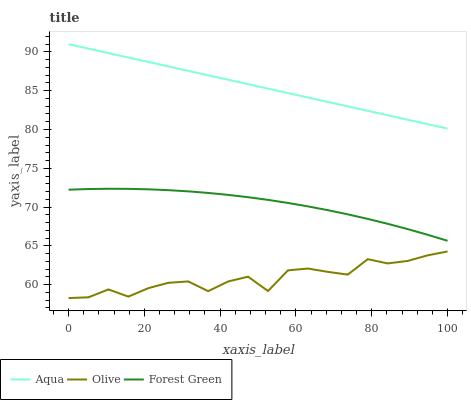Does Olive have the minimum area under the curve?
Answer yes or no. Yes. Does Aqua have the maximum area under the curve?
Answer yes or no. Yes. Does Forest Green have the minimum area under the curve?
Answer yes or no. No. Does Forest Green have the maximum area under the curve?
Answer yes or no. No. Is Aqua the smoothest?
Answer yes or no. Yes. Is Olive the roughest?
Answer yes or no. Yes. Is Forest Green the smoothest?
Answer yes or no. No. Is Forest Green the roughest?
Answer yes or no. No. Does Forest Green have the lowest value?
Answer yes or no. No. Does Aqua have the highest value?
Answer yes or no. Yes. Does Forest Green have the highest value?
Answer yes or no. No. Is Olive less than Forest Green?
Answer yes or no. Yes. Is Aqua greater than Forest Green?
Answer yes or no. Yes. Does Olive intersect Forest Green?
Answer yes or no. No. 